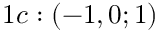<formula> <loc_0><loc_0><loc_500><loc_500>1 c \colon ( - 1 , 0 ; 1 )</formula> 